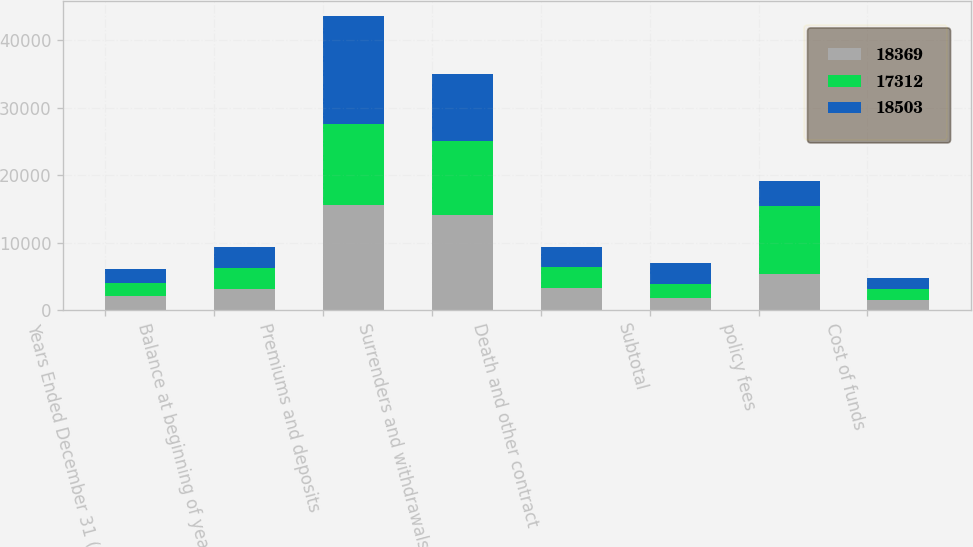Convert chart. <chart><loc_0><loc_0><loc_500><loc_500><stacked_bar_chart><ecel><fcel>Years Ended December 31 (in<fcel>Balance at beginning of year<fcel>Premiums and deposits<fcel>Surrenders and withdrawals<fcel>Death and other contract<fcel>Subtotal<fcel>policy fees<fcel>Cost of funds<nl><fcel>18369<fcel>2018<fcel>3089<fcel>15621<fcel>14081<fcel>3316<fcel>1776<fcel>5302<fcel>1540<nl><fcel>17312<fcel>2017<fcel>3089<fcel>11906<fcel>10943<fcel>3089<fcel>2126<fcel>10098<fcel>1528<nl><fcel>18503<fcel>2016<fcel>3089<fcel>16062<fcel>10027<fcel>2991<fcel>3044<fcel>3657<fcel>1614<nl></chart> 